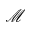<formula> <loc_0><loc_0><loc_500><loc_500>\mathcal { M }</formula> 